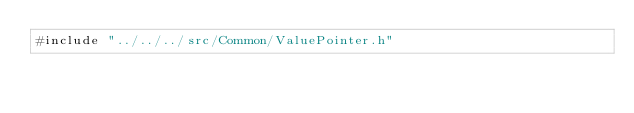Convert code to text. <code><loc_0><loc_0><loc_500><loc_500><_C_>#include "../../../src/Common/ValuePointer.h"
</code> 